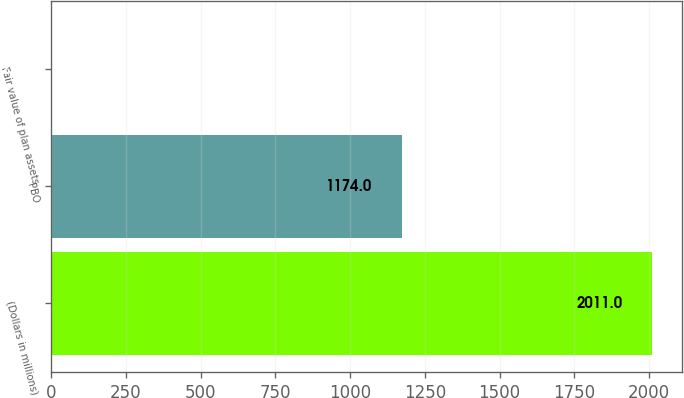Convert chart. <chart><loc_0><loc_0><loc_500><loc_500><bar_chart><fcel>(Dollars in millions)<fcel>PBO<fcel>Fair value of plan assets<nl><fcel>2011<fcel>1174<fcel>2<nl></chart> 